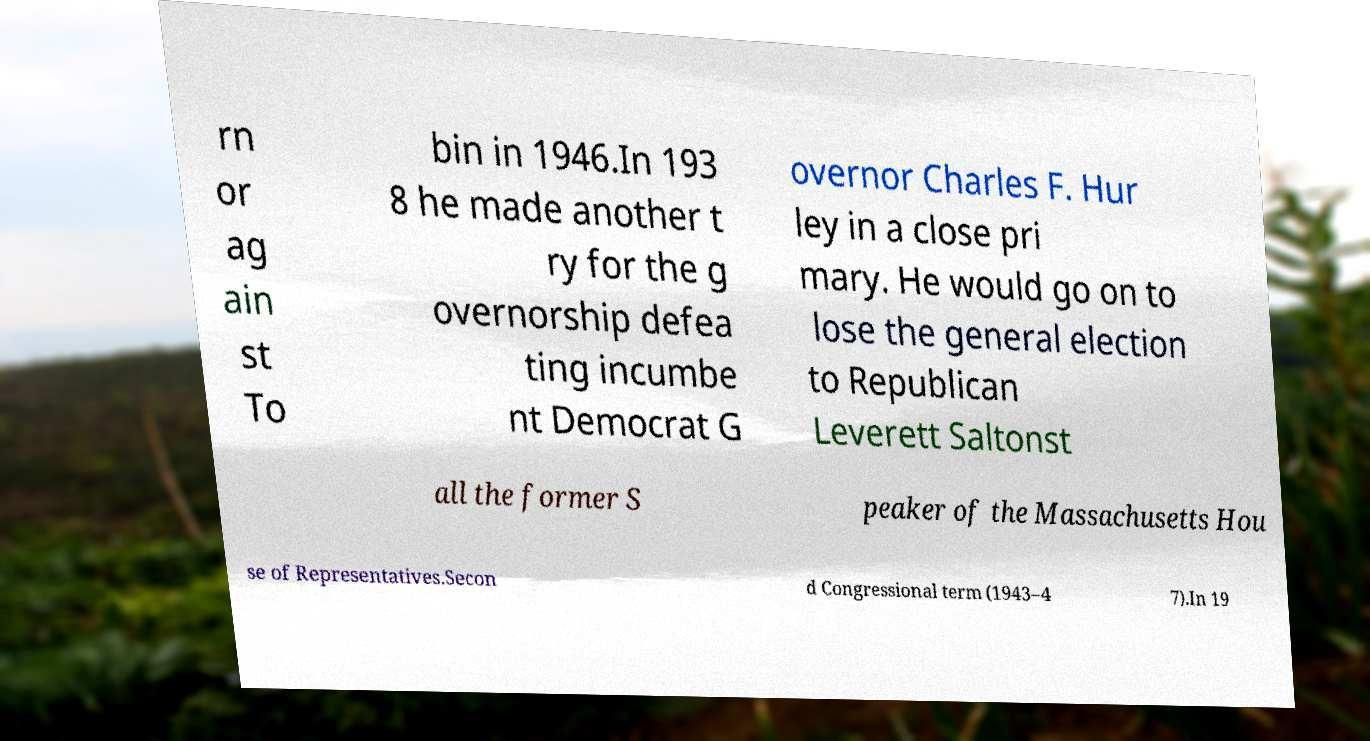For documentation purposes, I need the text within this image transcribed. Could you provide that? rn or ag ain st To bin in 1946.In 193 8 he made another t ry for the g overnorship defea ting incumbe nt Democrat G overnor Charles F. Hur ley in a close pri mary. He would go on to lose the general election to Republican Leverett Saltonst all the former S peaker of the Massachusetts Hou se of Representatives.Secon d Congressional term (1943–4 7).In 19 